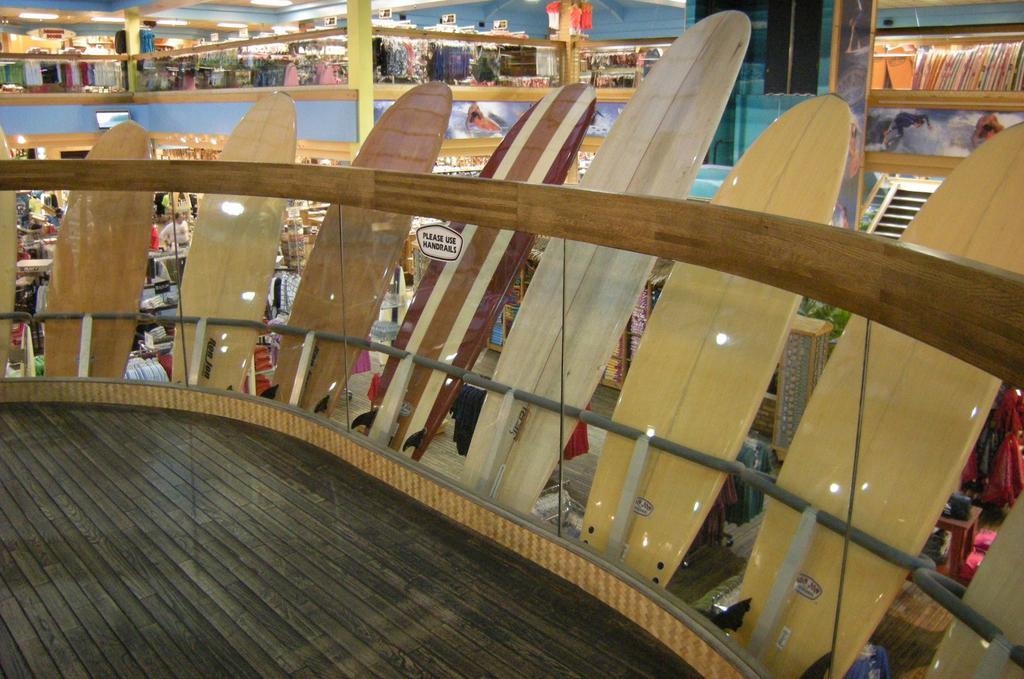In one or two sentences, can you explain what this image depicts? In this image I can see a shopping mall , on the mall I can see few cloths and in the foreground I can see there are boards attached tot eh glass fence and I can see lighting on boards. 